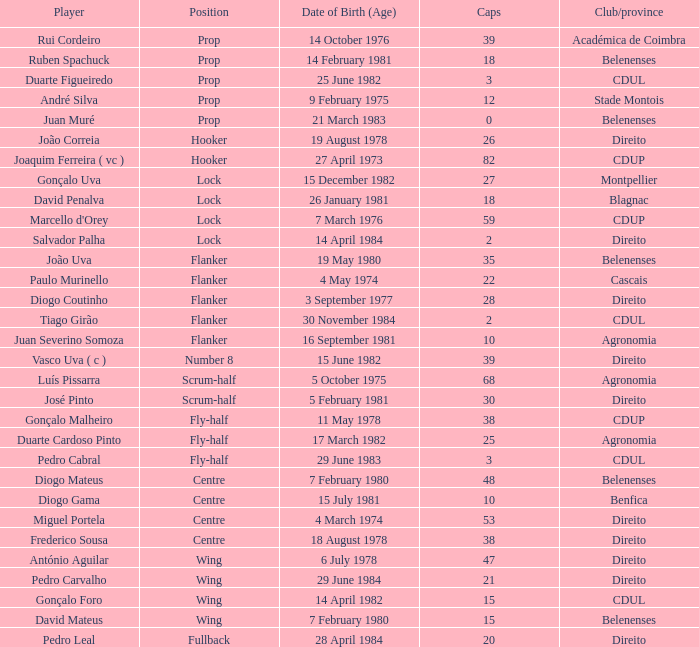Which player has a Position of fly-half, and a Caps of 3? Pedro Cabral. 